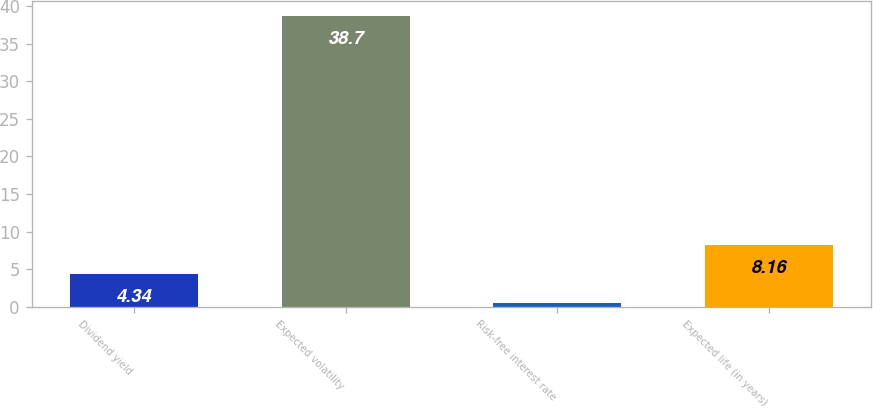<chart> <loc_0><loc_0><loc_500><loc_500><bar_chart><fcel>Dividend yield<fcel>Expected volatility<fcel>Risk-free interest rate<fcel>Expected life (in years)<nl><fcel>4.34<fcel>38.7<fcel>0.52<fcel>8.16<nl></chart> 